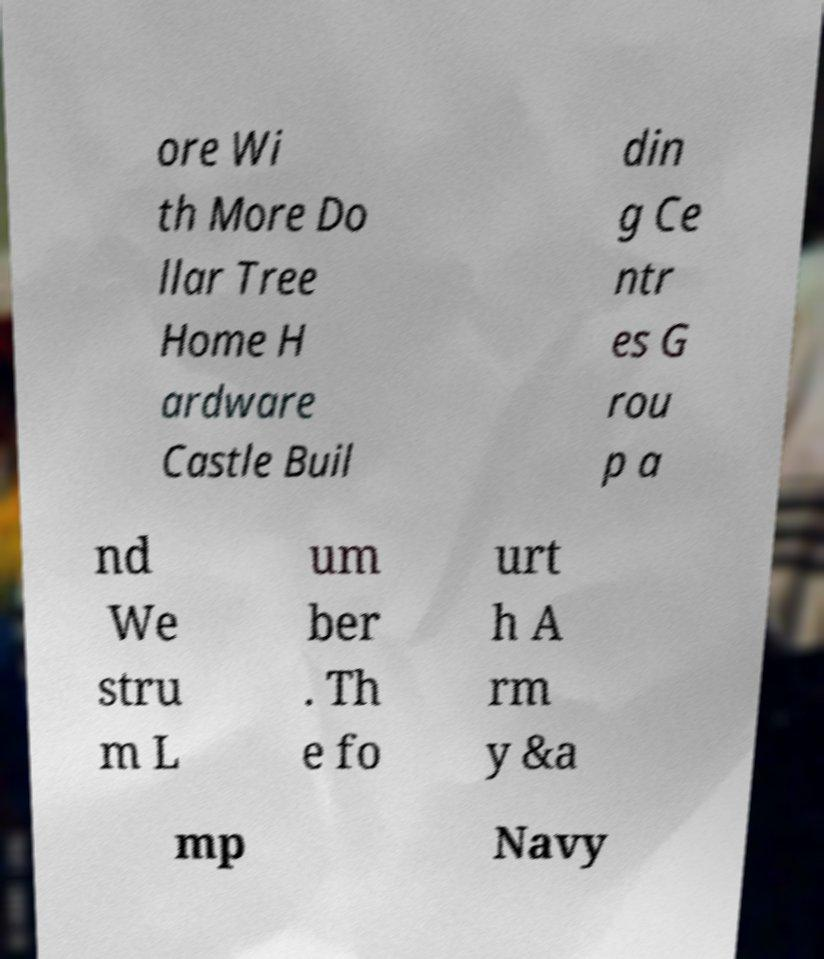I need the written content from this picture converted into text. Can you do that? ore Wi th More Do llar Tree Home H ardware Castle Buil din g Ce ntr es G rou p a nd We stru m L um ber . Th e fo urt h A rm y &a mp Navy 